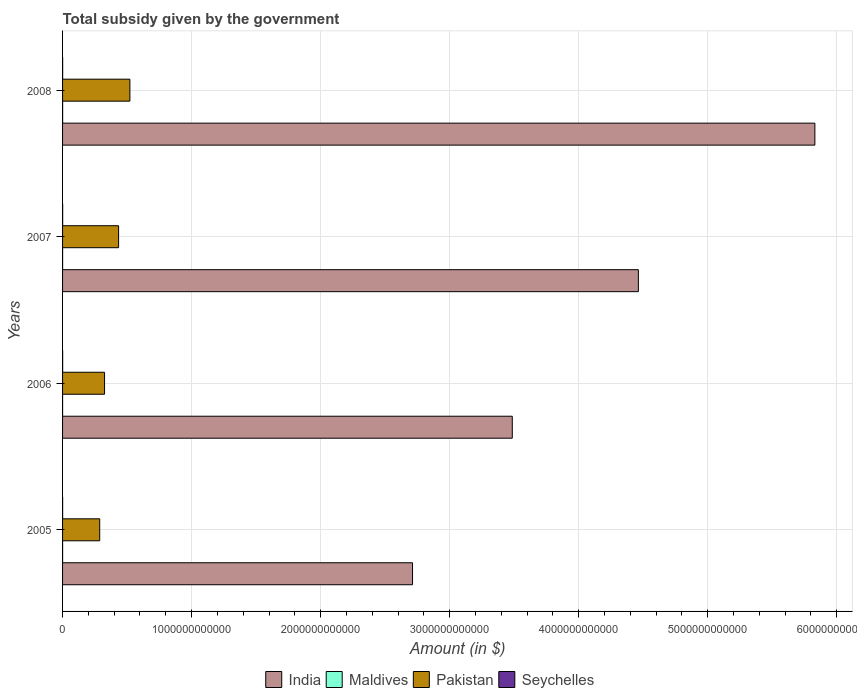How many different coloured bars are there?
Keep it short and to the point. 4. How many groups of bars are there?
Give a very brief answer. 4. Are the number of bars per tick equal to the number of legend labels?
Your answer should be compact. Yes. What is the label of the 1st group of bars from the top?
Offer a terse response. 2008. In how many cases, is the number of bars for a given year not equal to the number of legend labels?
Keep it short and to the point. 0. What is the total revenue collected by the government in Maldives in 2007?
Your response must be concise. 1.68e+08. Across all years, what is the maximum total revenue collected by the government in Pakistan?
Keep it short and to the point. 5.22e+11. Across all years, what is the minimum total revenue collected by the government in Seychelles?
Give a very brief answer. 4.17e+08. In which year was the total revenue collected by the government in Maldives maximum?
Offer a very short reply. 2008. What is the total total revenue collected by the government in Pakistan in the graph?
Offer a very short reply. 1.57e+12. What is the difference between the total revenue collected by the government in Pakistan in 2005 and that in 2007?
Provide a short and direct response. -1.46e+11. What is the difference between the total revenue collected by the government in Seychelles in 2006 and the total revenue collected by the government in Pakistan in 2007?
Offer a very short reply. -4.34e+11. What is the average total revenue collected by the government in Maldives per year?
Ensure brevity in your answer.  2.56e+08. In the year 2005, what is the difference between the total revenue collected by the government in Pakistan and total revenue collected by the government in India?
Offer a very short reply. -2.42e+12. In how many years, is the total revenue collected by the government in Pakistan greater than 5000000000000 $?
Provide a short and direct response. 0. What is the ratio of the total revenue collected by the government in Maldives in 2005 to that in 2008?
Ensure brevity in your answer.  0.47. Is the difference between the total revenue collected by the government in Pakistan in 2005 and 2007 greater than the difference between the total revenue collected by the government in India in 2005 and 2007?
Give a very brief answer. Yes. What is the difference between the highest and the second highest total revenue collected by the government in India?
Make the answer very short. 1.37e+12. What is the difference between the highest and the lowest total revenue collected by the government in Maldives?
Offer a very short reply. 3.29e+08. In how many years, is the total revenue collected by the government in Maldives greater than the average total revenue collected by the government in Maldives taken over all years?
Ensure brevity in your answer.  1. Is it the case that in every year, the sum of the total revenue collected by the government in Seychelles and total revenue collected by the government in India is greater than the sum of total revenue collected by the government in Pakistan and total revenue collected by the government in Maldives?
Provide a succinct answer. No. What does the 3rd bar from the bottom in 2006 represents?
Make the answer very short. Pakistan. How many years are there in the graph?
Give a very brief answer. 4. What is the difference between two consecutive major ticks on the X-axis?
Your answer should be compact. 1.00e+12. Are the values on the major ticks of X-axis written in scientific E-notation?
Provide a succinct answer. No. Does the graph contain any zero values?
Ensure brevity in your answer.  No. Where does the legend appear in the graph?
Your response must be concise. Bottom center. What is the title of the graph?
Offer a terse response. Total subsidy given by the government. What is the label or title of the X-axis?
Give a very brief answer. Amount (in $). What is the Amount (in $) of India in 2005?
Offer a terse response. 2.71e+12. What is the Amount (in $) of Maldives in 2005?
Provide a short and direct response. 2.28e+08. What is the Amount (in $) in Pakistan in 2005?
Offer a terse response. 2.88e+11. What is the Amount (in $) in Seychelles in 2005?
Your answer should be compact. 4.17e+08. What is the Amount (in $) of India in 2006?
Offer a very short reply. 3.49e+12. What is the Amount (in $) in Maldives in 2006?
Make the answer very short. 1.50e+08. What is the Amount (in $) in Pakistan in 2006?
Your response must be concise. 3.25e+11. What is the Amount (in $) of Seychelles in 2006?
Keep it short and to the point. 5.37e+08. What is the Amount (in $) in India in 2007?
Give a very brief answer. 4.46e+12. What is the Amount (in $) of Maldives in 2007?
Give a very brief answer. 1.68e+08. What is the Amount (in $) of Pakistan in 2007?
Keep it short and to the point. 4.34e+11. What is the Amount (in $) in Seychelles in 2007?
Keep it short and to the point. 6.78e+08. What is the Amount (in $) of India in 2008?
Offer a terse response. 5.83e+12. What is the Amount (in $) in Maldives in 2008?
Make the answer very short. 4.79e+08. What is the Amount (in $) of Pakistan in 2008?
Make the answer very short. 5.22e+11. What is the Amount (in $) of Seychelles in 2008?
Your answer should be very brief. 6.32e+08. Across all years, what is the maximum Amount (in $) in India?
Ensure brevity in your answer.  5.83e+12. Across all years, what is the maximum Amount (in $) in Maldives?
Your answer should be compact. 4.79e+08. Across all years, what is the maximum Amount (in $) of Pakistan?
Provide a short and direct response. 5.22e+11. Across all years, what is the maximum Amount (in $) in Seychelles?
Your answer should be compact. 6.78e+08. Across all years, what is the minimum Amount (in $) of India?
Ensure brevity in your answer.  2.71e+12. Across all years, what is the minimum Amount (in $) of Maldives?
Offer a very short reply. 1.50e+08. Across all years, what is the minimum Amount (in $) in Pakistan?
Keep it short and to the point. 2.88e+11. Across all years, what is the minimum Amount (in $) of Seychelles?
Provide a short and direct response. 4.17e+08. What is the total Amount (in $) in India in the graph?
Offer a terse response. 1.65e+13. What is the total Amount (in $) in Maldives in the graph?
Give a very brief answer. 1.02e+09. What is the total Amount (in $) in Pakistan in the graph?
Provide a short and direct response. 1.57e+12. What is the total Amount (in $) in Seychelles in the graph?
Your response must be concise. 2.26e+09. What is the difference between the Amount (in $) of India in 2005 and that in 2006?
Your answer should be compact. -7.73e+11. What is the difference between the Amount (in $) of Maldives in 2005 and that in 2006?
Make the answer very short. 7.77e+07. What is the difference between the Amount (in $) in Pakistan in 2005 and that in 2006?
Provide a short and direct response. -3.74e+1. What is the difference between the Amount (in $) in Seychelles in 2005 and that in 2006?
Offer a very short reply. -1.20e+08. What is the difference between the Amount (in $) in India in 2005 and that in 2007?
Your answer should be compact. -1.75e+12. What is the difference between the Amount (in $) in Maldives in 2005 and that in 2007?
Offer a terse response. 5.92e+07. What is the difference between the Amount (in $) of Pakistan in 2005 and that in 2007?
Your response must be concise. -1.46e+11. What is the difference between the Amount (in $) in Seychelles in 2005 and that in 2007?
Make the answer very short. -2.61e+08. What is the difference between the Amount (in $) in India in 2005 and that in 2008?
Your answer should be very brief. -3.12e+12. What is the difference between the Amount (in $) of Maldives in 2005 and that in 2008?
Ensure brevity in your answer.  -2.52e+08. What is the difference between the Amount (in $) in Pakistan in 2005 and that in 2008?
Provide a short and direct response. -2.34e+11. What is the difference between the Amount (in $) of Seychelles in 2005 and that in 2008?
Give a very brief answer. -2.16e+08. What is the difference between the Amount (in $) of India in 2006 and that in 2007?
Offer a very short reply. -9.77e+11. What is the difference between the Amount (in $) in Maldives in 2006 and that in 2007?
Ensure brevity in your answer.  -1.85e+07. What is the difference between the Amount (in $) of Pakistan in 2006 and that in 2007?
Offer a terse response. -1.09e+11. What is the difference between the Amount (in $) in Seychelles in 2006 and that in 2007?
Make the answer very short. -1.41e+08. What is the difference between the Amount (in $) of India in 2006 and that in 2008?
Give a very brief answer. -2.35e+12. What is the difference between the Amount (in $) in Maldives in 2006 and that in 2008?
Offer a terse response. -3.29e+08. What is the difference between the Amount (in $) of Pakistan in 2006 and that in 2008?
Provide a short and direct response. -1.96e+11. What is the difference between the Amount (in $) in Seychelles in 2006 and that in 2008?
Your answer should be compact. -9.57e+07. What is the difference between the Amount (in $) in India in 2007 and that in 2008?
Provide a succinct answer. -1.37e+12. What is the difference between the Amount (in $) of Maldives in 2007 and that in 2008?
Your answer should be very brief. -3.11e+08. What is the difference between the Amount (in $) of Pakistan in 2007 and that in 2008?
Your response must be concise. -8.75e+1. What is the difference between the Amount (in $) in Seychelles in 2007 and that in 2008?
Your answer should be compact. 4.56e+07. What is the difference between the Amount (in $) in India in 2005 and the Amount (in $) in Maldives in 2006?
Ensure brevity in your answer.  2.71e+12. What is the difference between the Amount (in $) in India in 2005 and the Amount (in $) in Pakistan in 2006?
Ensure brevity in your answer.  2.39e+12. What is the difference between the Amount (in $) of India in 2005 and the Amount (in $) of Seychelles in 2006?
Offer a very short reply. 2.71e+12. What is the difference between the Amount (in $) of Maldives in 2005 and the Amount (in $) of Pakistan in 2006?
Your answer should be very brief. -3.25e+11. What is the difference between the Amount (in $) in Maldives in 2005 and the Amount (in $) in Seychelles in 2006?
Provide a short and direct response. -3.09e+08. What is the difference between the Amount (in $) of Pakistan in 2005 and the Amount (in $) of Seychelles in 2006?
Provide a short and direct response. 2.87e+11. What is the difference between the Amount (in $) in India in 2005 and the Amount (in $) in Maldives in 2007?
Give a very brief answer. 2.71e+12. What is the difference between the Amount (in $) in India in 2005 and the Amount (in $) in Pakistan in 2007?
Your answer should be compact. 2.28e+12. What is the difference between the Amount (in $) in India in 2005 and the Amount (in $) in Seychelles in 2007?
Offer a very short reply. 2.71e+12. What is the difference between the Amount (in $) of Maldives in 2005 and the Amount (in $) of Pakistan in 2007?
Your answer should be compact. -4.34e+11. What is the difference between the Amount (in $) in Maldives in 2005 and the Amount (in $) in Seychelles in 2007?
Ensure brevity in your answer.  -4.51e+08. What is the difference between the Amount (in $) of Pakistan in 2005 and the Amount (in $) of Seychelles in 2007?
Keep it short and to the point. 2.87e+11. What is the difference between the Amount (in $) of India in 2005 and the Amount (in $) of Maldives in 2008?
Provide a succinct answer. 2.71e+12. What is the difference between the Amount (in $) of India in 2005 and the Amount (in $) of Pakistan in 2008?
Give a very brief answer. 2.19e+12. What is the difference between the Amount (in $) of India in 2005 and the Amount (in $) of Seychelles in 2008?
Your answer should be compact. 2.71e+12. What is the difference between the Amount (in $) in Maldives in 2005 and the Amount (in $) in Pakistan in 2008?
Provide a short and direct response. -5.22e+11. What is the difference between the Amount (in $) of Maldives in 2005 and the Amount (in $) of Seychelles in 2008?
Ensure brevity in your answer.  -4.05e+08. What is the difference between the Amount (in $) in Pakistan in 2005 and the Amount (in $) in Seychelles in 2008?
Make the answer very short. 2.87e+11. What is the difference between the Amount (in $) of India in 2006 and the Amount (in $) of Maldives in 2007?
Offer a terse response. 3.48e+12. What is the difference between the Amount (in $) of India in 2006 and the Amount (in $) of Pakistan in 2007?
Your answer should be compact. 3.05e+12. What is the difference between the Amount (in $) of India in 2006 and the Amount (in $) of Seychelles in 2007?
Provide a short and direct response. 3.48e+12. What is the difference between the Amount (in $) in Maldives in 2006 and the Amount (in $) in Pakistan in 2007?
Give a very brief answer. -4.34e+11. What is the difference between the Amount (in $) in Maldives in 2006 and the Amount (in $) in Seychelles in 2007?
Make the answer very short. -5.28e+08. What is the difference between the Amount (in $) in Pakistan in 2006 and the Amount (in $) in Seychelles in 2007?
Provide a short and direct response. 3.25e+11. What is the difference between the Amount (in $) of India in 2006 and the Amount (in $) of Maldives in 2008?
Your answer should be compact. 3.48e+12. What is the difference between the Amount (in $) in India in 2006 and the Amount (in $) in Pakistan in 2008?
Provide a succinct answer. 2.96e+12. What is the difference between the Amount (in $) in India in 2006 and the Amount (in $) in Seychelles in 2008?
Offer a very short reply. 3.48e+12. What is the difference between the Amount (in $) of Maldives in 2006 and the Amount (in $) of Pakistan in 2008?
Your answer should be compact. -5.22e+11. What is the difference between the Amount (in $) of Maldives in 2006 and the Amount (in $) of Seychelles in 2008?
Provide a succinct answer. -4.83e+08. What is the difference between the Amount (in $) in Pakistan in 2006 and the Amount (in $) in Seychelles in 2008?
Your answer should be very brief. 3.25e+11. What is the difference between the Amount (in $) in India in 2007 and the Amount (in $) in Maldives in 2008?
Your response must be concise. 4.46e+12. What is the difference between the Amount (in $) in India in 2007 and the Amount (in $) in Pakistan in 2008?
Provide a short and direct response. 3.94e+12. What is the difference between the Amount (in $) of India in 2007 and the Amount (in $) of Seychelles in 2008?
Provide a succinct answer. 4.46e+12. What is the difference between the Amount (in $) in Maldives in 2007 and the Amount (in $) in Pakistan in 2008?
Keep it short and to the point. -5.22e+11. What is the difference between the Amount (in $) of Maldives in 2007 and the Amount (in $) of Seychelles in 2008?
Keep it short and to the point. -4.64e+08. What is the difference between the Amount (in $) in Pakistan in 2007 and the Amount (in $) in Seychelles in 2008?
Give a very brief answer. 4.34e+11. What is the average Amount (in $) of India per year?
Your response must be concise. 4.12e+12. What is the average Amount (in $) of Maldives per year?
Your answer should be very brief. 2.56e+08. What is the average Amount (in $) of Pakistan per year?
Your answer should be very brief. 3.92e+11. What is the average Amount (in $) in Seychelles per year?
Your answer should be compact. 5.66e+08. In the year 2005, what is the difference between the Amount (in $) in India and Amount (in $) in Maldives?
Your response must be concise. 2.71e+12. In the year 2005, what is the difference between the Amount (in $) in India and Amount (in $) in Pakistan?
Make the answer very short. 2.42e+12. In the year 2005, what is the difference between the Amount (in $) of India and Amount (in $) of Seychelles?
Your response must be concise. 2.71e+12. In the year 2005, what is the difference between the Amount (in $) in Maldives and Amount (in $) in Pakistan?
Give a very brief answer. -2.88e+11. In the year 2005, what is the difference between the Amount (in $) in Maldives and Amount (in $) in Seychelles?
Make the answer very short. -1.89e+08. In the year 2005, what is the difference between the Amount (in $) of Pakistan and Amount (in $) of Seychelles?
Offer a terse response. 2.87e+11. In the year 2006, what is the difference between the Amount (in $) in India and Amount (in $) in Maldives?
Your answer should be compact. 3.48e+12. In the year 2006, what is the difference between the Amount (in $) in India and Amount (in $) in Pakistan?
Ensure brevity in your answer.  3.16e+12. In the year 2006, what is the difference between the Amount (in $) in India and Amount (in $) in Seychelles?
Your answer should be compact. 3.48e+12. In the year 2006, what is the difference between the Amount (in $) of Maldives and Amount (in $) of Pakistan?
Make the answer very short. -3.25e+11. In the year 2006, what is the difference between the Amount (in $) in Maldives and Amount (in $) in Seychelles?
Keep it short and to the point. -3.87e+08. In the year 2006, what is the difference between the Amount (in $) of Pakistan and Amount (in $) of Seychelles?
Your answer should be very brief. 3.25e+11. In the year 2007, what is the difference between the Amount (in $) of India and Amount (in $) of Maldives?
Your answer should be very brief. 4.46e+12. In the year 2007, what is the difference between the Amount (in $) in India and Amount (in $) in Pakistan?
Offer a very short reply. 4.03e+12. In the year 2007, what is the difference between the Amount (in $) in India and Amount (in $) in Seychelles?
Your answer should be very brief. 4.46e+12. In the year 2007, what is the difference between the Amount (in $) in Maldives and Amount (in $) in Pakistan?
Make the answer very short. -4.34e+11. In the year 2007, what is the difference between the Amount (in $) in Maldives and Amount (in $) in Seychelles?
Provide a succinct answer. -5.10e+08. In the year 2007, what is the difference between the Amount (in $) of Pakistan and Amount (in $) of Seychelles?
Give a very brief answer. 4.34e+11. In the year 2008, what is the difference between the Amount (in $) in India and Amount (in $) in Maldives?
Offer a terse response. 5.83e+12. In the year 2008, what is the difference between the Amount (in $) of India and Amount (in $) of Pakistan?
Give a very brief answer. 5.31e+12. In the year 2008, what is the difference between the Amount (in $) in India and Amount (in $) in Seychelles?
Offer a terse response. 5.83e+12. In the year 2008, what is the difference between the Amount (in $) in Maldives and Amount (in $) in Pakistan?
Offer a terse response. -5.21e+11. In the year 2008, what is the difference between the Amount (in $) of Maldives and Amount (in $) of Seychelles?
Offer a terse response. -1.53e+08. In the year 2008, what is the difference between the Amount (in $) of Pakistan and Amount (in $) of Seychelles?
Make the answer very short. 5.21e+11. What is the ratio of the Amount (in $) in India in 2005 to that in 2006?
Provide a succinct answer. 0.78. What is the ratio of the Amount (in $) of Maldives in 2005 to that in 2006?
Your answer should be compact. 1.52. What is the ratio of the Amount (in $) of Pakistan in 2005 to that in 2006?
Provide a short and direct response. 0.89. What is the ratio of the Amount (in $) of Seychelles in 2005 to that in 2006?
Your response must be concise. 0.78. What is the ratio of the Amount (in $) in India in 2005 to that in 2007?
Your answer should be very brief. 0.61. What is the ratio of the Amount (in $) in Maldives in 2005 to that in 2007?
Provide a succinct answer. 1.35. What is the ratio of the Amount (in $) in Pakistan in 2005 to that in 2007?
Your response must be concise. 0.66. What is the ratio of the Amount (in $) in Seychelles in 2005 to that in 2007?
Your response must be concise. 0.61. What is the ratio of the Amount (in $) of India in 2005 to that in 2008?
Give a very brief answer. 0.47. What is the ratio of the Amount (in $) in Maldives in 2005 to that in 2008?
Ensure brevity in your answer.  0.47. What is the ratio of the Amount (in $) in Pakistan in 2005 to that in 2008?
Provide a succinct answer. 0.55. What is the ratio of the Amount (in $) in Seychelles in 2005 to that in 2008?
Your answer should be compact. 0.66. What is the ratio of the Amount (in $) of India in 2006 to that in 2007?
Your response must be concise. 0.78. What is the ratio of the Amount (in $) in Maldives in 2006 to that in 2007?
Provide a succinct answer. 0.89. What is the ratio of the Amount (in $) of Pakistan in 2006 to that in 2007?
Your answer should be very brief. 0.75. What is the ratio of the Amount (in $) in Seychelles in 2006 to that in 2007?
Ensure brevity in your answer.  0.79. What is the ratio of the Amount (in $) in India in 2006 to that in 2008?
Provide a short and direct response. 0.6. What is the ratio of the Amount (in $) of Maldives in 2006 to that in 2008?
Give a very brief answer. 0.31. What is the ratio of the Amount (in $) in Pakistan in 2006 to that in 2008?
Your answer should be very brief. 0.62. What is the ratio of the Amount (in $) in Seychelles in 2006 to that in 2008?
Offer a terse response. 0.85. What is the ratio of the Amount (in $) in India in 2007 to that in 2008?
Give a very brief answer. 0.77. What is the ratio of the Amount (in $) of Maldives in 2007 to that in 2008?
Make the answer very short. 0.35. What is the ratio of the Amount (in $) of Pakistan in 2007 to that in 2008?
Offer a terse response. 0.83. What is the ratio of the Amount (in $) of Seychelles in 2007 to that in 2008?
Give a very brief answer. 1.07. What is the difference between the highest and the second highest Amount (in $) in India?
Provide a short and direct response. 1.37e+12. What is the difference between the highest and the second highest Amount (in $) of Maldives?
Your answer should be very brief. 2.52e+08. What is the difference between the highest and the second highest Amount (in $) of Pakistan?
Your answer should be compact. 8.75e+1. What is the difference between the highest and the second highest Amount (in $) in Seychelles?
Give a very brief answer. 4.56e+07. What is the difference between the highest and the lowest Amount (in $) in India?
Offer a very short reply. 3.12e+12. What is the difference between the highest and the lowest Amount (in $) of Maldives?
Provide a short and direct response. 3.29e+08. What is the difference between the highest and the lowest Amount (in $) of Pakistan?
Offer a very short reply. 2.34e+11. What is the difference between the highest and the lowest Amount (in $) of Seychelles?
Keep it short and to the point. 2.61e+08. 